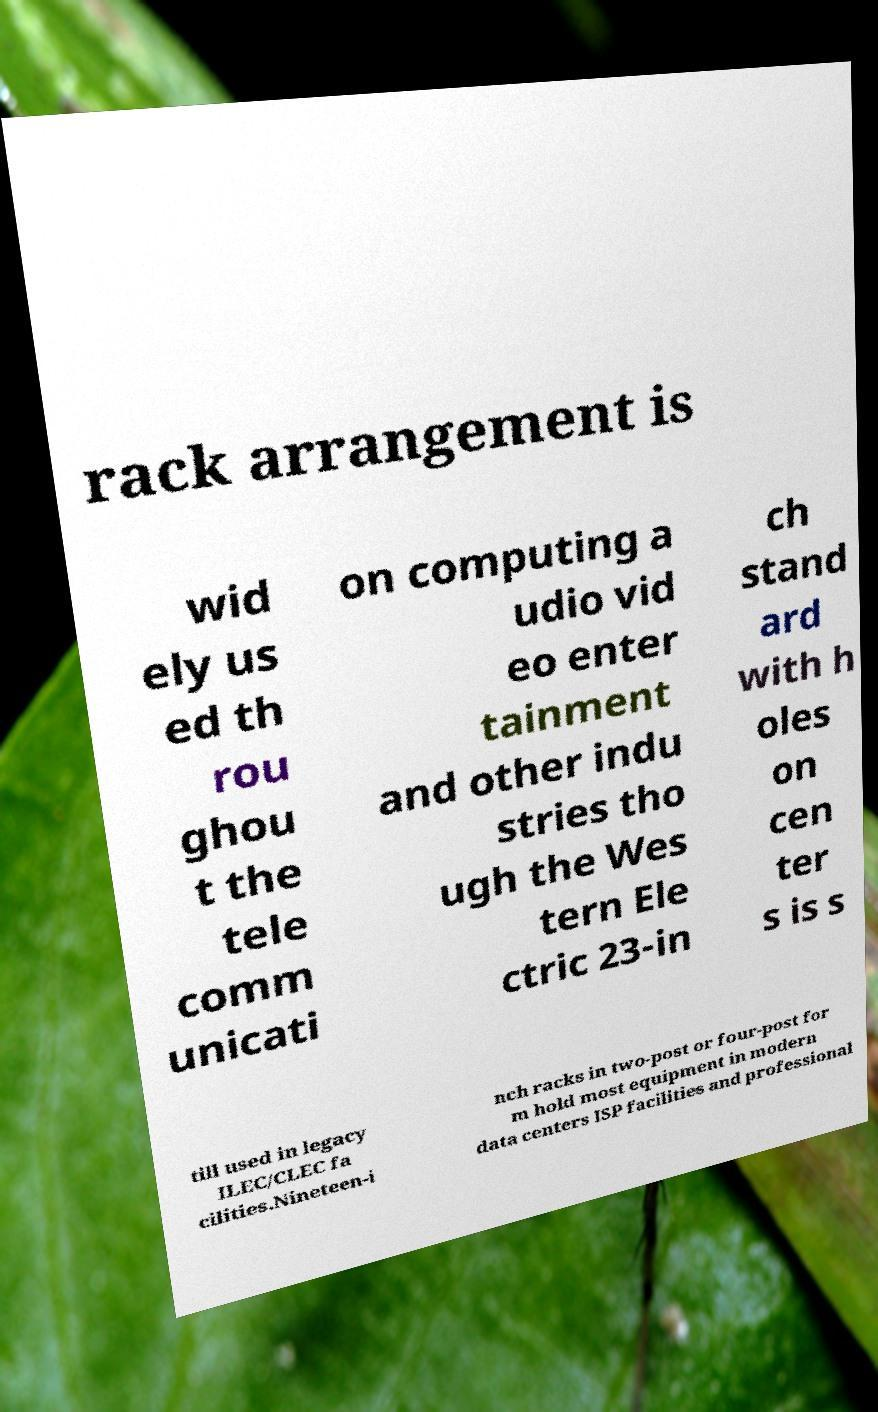For documentation purposes, I need the text within this image transcribed. Could you provide that? rack arrangement is wid ely us ed th rou ghou t the tele comm unicati on computing a udio vid eo enter tainment and other indu stries tho ugh the Wes tern Ele ctric 23-in ch stand ard with h oles on cen ter s is s till used in legacy ILEC/CLEC fa cilities.Nineteen-i nch racks in two-post or four-post for m hold most equipment in modern data centers ISP facilities and professional 